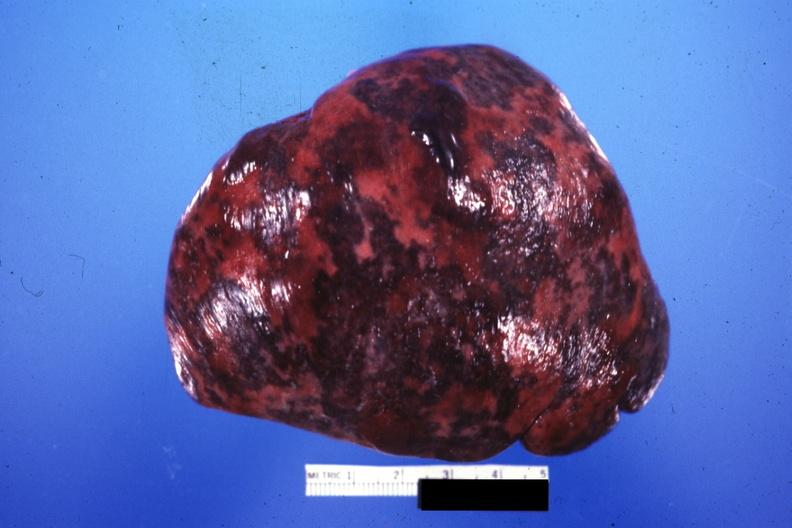what is present?
Answer the question using a single word or phrase. Hematologic 